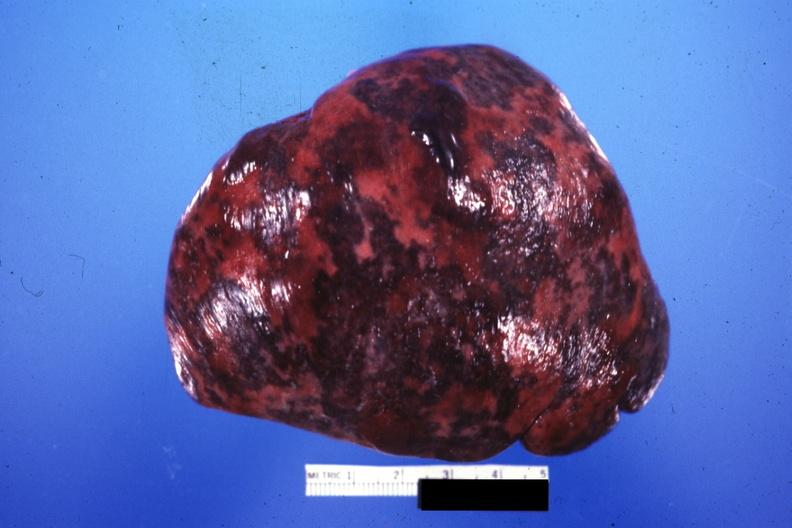what is present?
Answer the question using a single word or phrase. Hematologic 